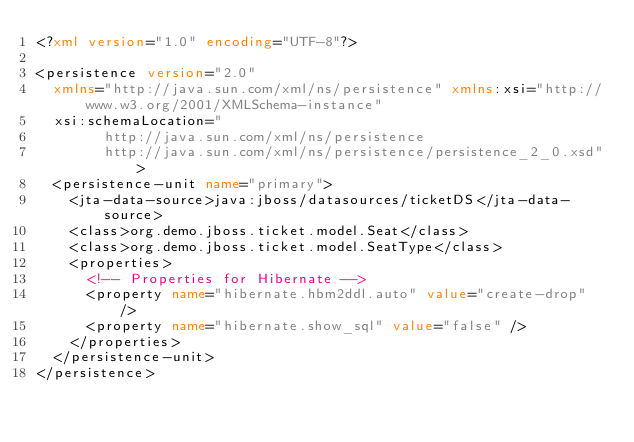Convert code to text. <code><loc_0><loc_0><loc_500><loc_500><_XML_><?xml version="1.0" encoding="UTF-8"?>

<persistence version="2.0"
	xmlns="http://java.sun.com/xml/ns/persistence" xmlns:xsi="http://www.w3.org/2001/XMLSchema-instance"
	xsi:schemaLocation="
        http://java.sun.com/xml/ns/persistence
        http://java.sun.com/xml/ns/persistence/persistence_2_0.xsd">
	<persistence-unit name="primary">
		<jta-data-source>java:jboss/datasources/ticketDS</jta-data-source>
		<class>org.demo.jboss.ticket.model.Seat</class>
		<class>org.demo.jboss.ticket.model.SeatType</class>
		<properties>
			<!-- Properties for Hibernate -->
			<property name="hibernate.hbm2ddl.auto" value="create-drop" />
			<property name="hibernate.show_sql" value="false" />
		</properties>
	</persistence-unit>
</persistence>
</code> 